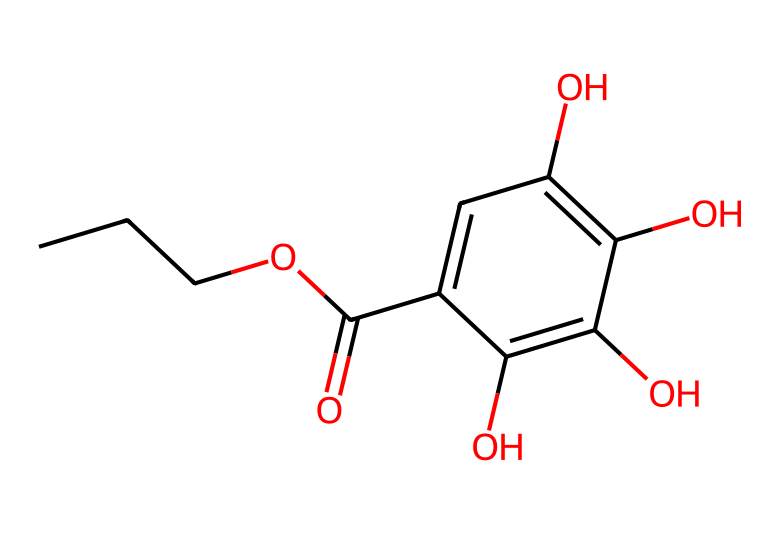What is the molecular formula of propyl gallate? To determine the molecular formula from the SMILES representation, we should identify the constituent atoms: the structure includes carbon (C), hydrogen (H), and oxygen (O). Counting the atoms leads us to the formula C10H12O5.
Answer: C10H12O5 How many hydroxyl (-OH) groups are present in propyl gallate? By closely examining the structure, we can see that there are four -OH groups attached to the aromatic ring. Each hydroxyl group is represented as an oxygen bonded to a hydrogen in the chemical structure.
Answer: 4 What type of chemical bond connects the carbon atoms in propyl gallate? In the structure, the carbon atoms are primarily connected by single bonds with some double bonds, specifically in the aromatic ring. Typically, these carbon-carbon connections are characterized as covalent bonds.
Answer: covalent What are the implications of the phenolic structure in propyl gallate? The presence of a phenolic structure (the aromatic ring with hydroxyl groups) is significant as it contributes to the antioxidant properties of propyl gallate, allowing it to donate electrons and neutralize free radicals.
Answer: antioxidant properties What functional groups are evident in propyl gallate? Assessing the structure reveals various functional groups, including hydroxyl (-OH) and ester (–COO–) functionalities. Identifying these groups contributes to understanding the chemical's reactivity and functionality.
Answer: hydroxyl and ester Does propyl gallate have any steroid or alkaloid characteristics? Looking at the provided structure, it is evident that propyl gallate does not possess steroid or alkaloid characteristics, as it lacks the steroid backbone and nitrogen atoms associated with alkaloids.
Answer: No 